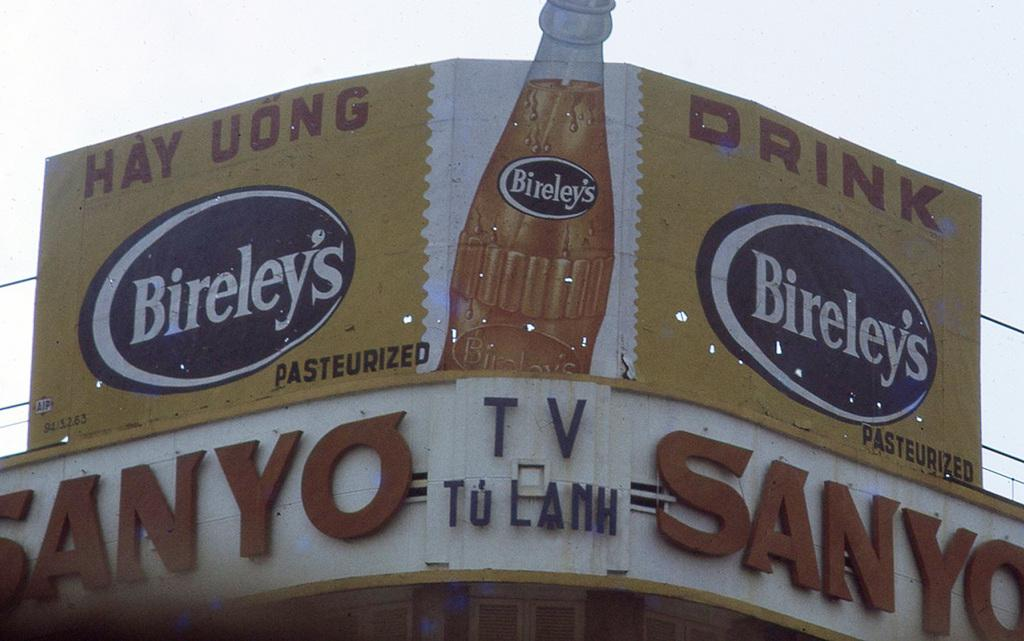<image>
Provide a brief description of the given image. A large billboard advertising the Japanese soft drink Bireley's. 